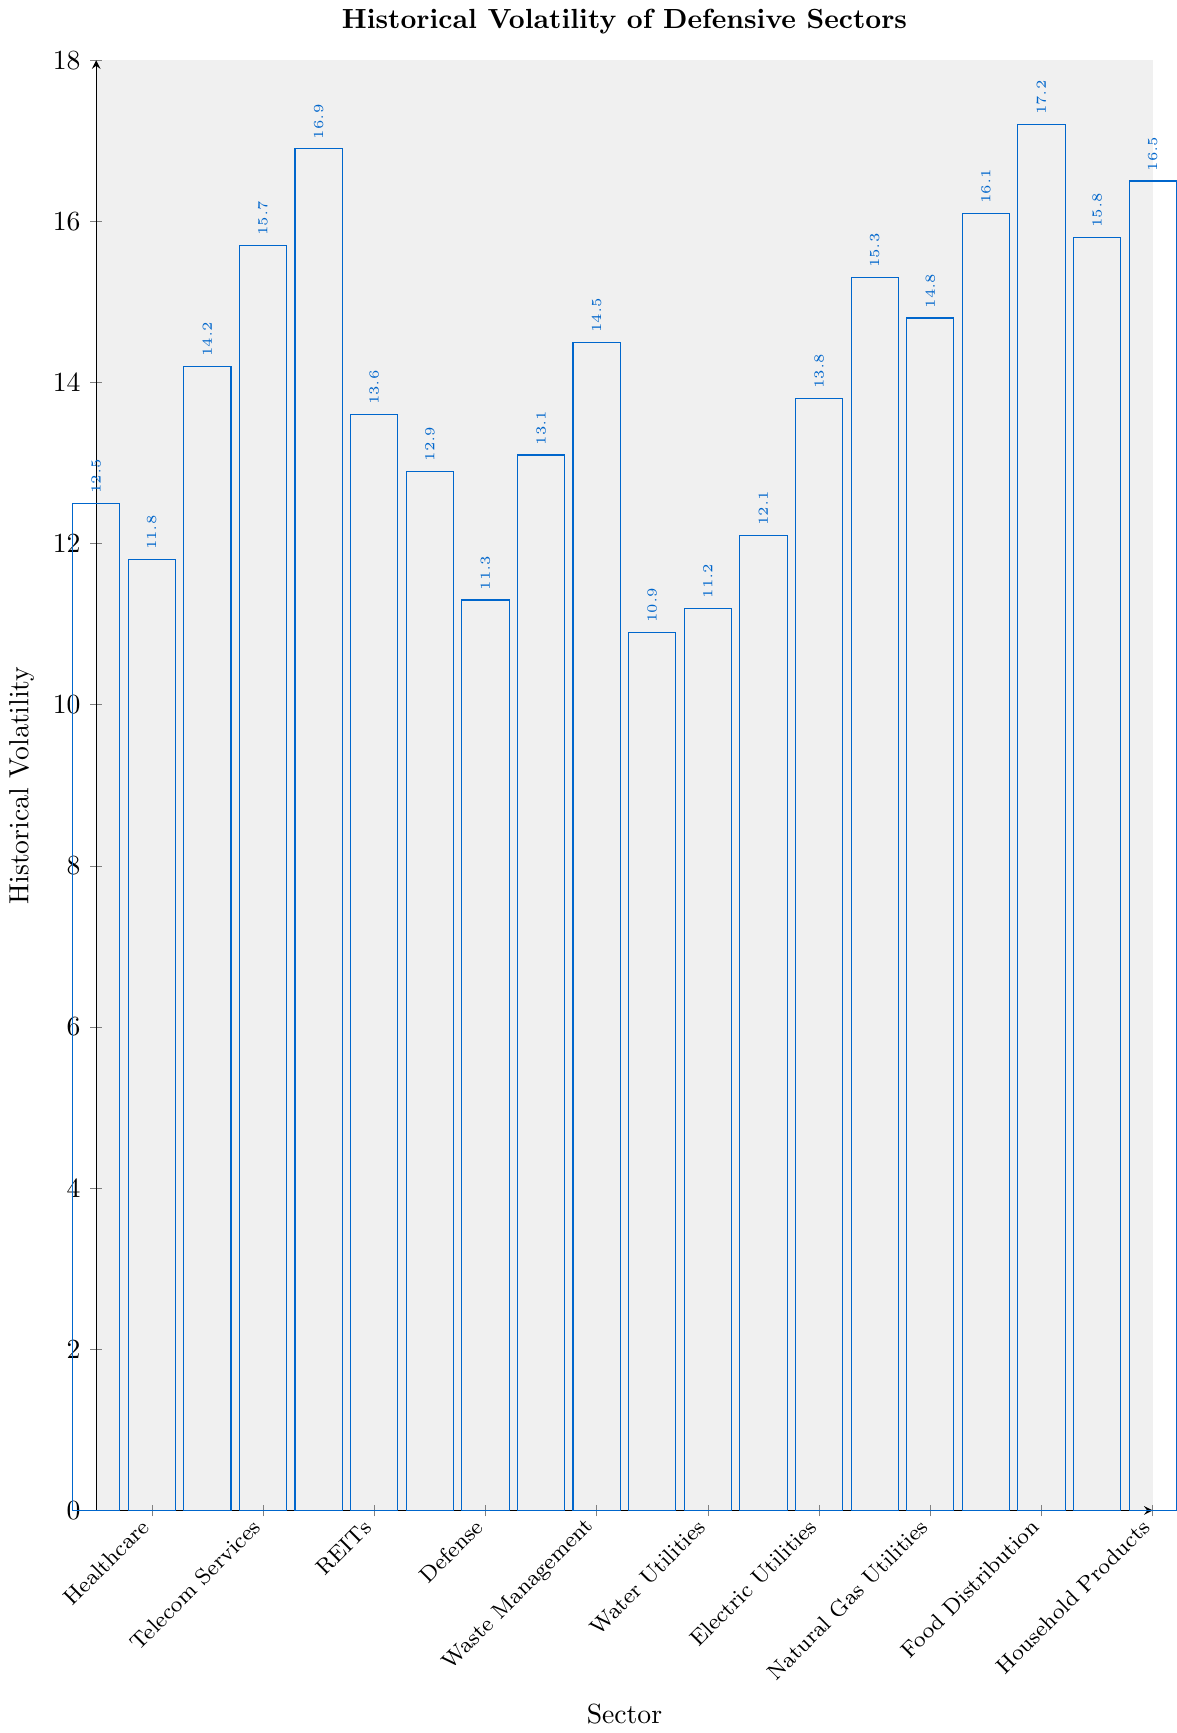Which sector has the lowest historical volatility? By visually examining the figure, observe which bar is the shortest. The shortest bar corresponds to the Food Distribution sector.
Answer: Food Distribution Which sector has the highest historical volatility? By visually examining the figure, observe which bar is the tallest. The tallest bar corresponds to the Wireless Telecommunication Services sector.
Answer: Wireless Telecommunication Services Among the Utilities sectors (Utilities, Water Utilities, Electric Utilities, and Natural Gas Utilities), which has the highest historical volatility? Identify the bars for the Utilities sectors by their position on the x-axis. Compare their heights and note that Natural Gas Utilities has the tallest bar among these.
Answer: Natural Gas Utilities What's the difference in historical volatility between the Healthcare and Managed Healthcare sectors? Locate the bars corresponding to Healthcare and Managed Healthcare. Healthcare's historical volatility is 14.2, while Managed Healthcare's is 14.8. The difference is 14.8 - 14.2.
Answer: 0.6 What is the average historical volatility of the Consumer Staples, Healthcare, and Defense sectors? Sum the historical volatilities of Consumer Staples (11.8), Healthcare (14.2), and Defense (13.6), then divide by the number of sectors: (11.8 + 14.2 + 13.6) / 3.
Answer: 13.2 What is the average historical volatility of all sectors shown in the figure? Sum up all the historical volatility values and divide by the number of sectors: (12.5 + 11.8 + 14.2 + 15.7 + 16.9 + 13.6 + 12.9 + 11.3 + 13.1 + 14.5 + 10.9 + 11.2 + 12.1 + 13.8 + 15.3 + 14.8 + 16.1 + 17.2 + 15.8 + 16.5) / 20.
Answer: 14.05 Which sector has slightly higher historical volatility: Beverages or Household Products? Compare the heights of the bars for Beverages and Household Products. Beverages has a historical volatility of 12.1, whereas Household Products has 11.2.
Answer: Beverages Among the sectors with historical volatility above 16, which has the lowest value? Identify sectors with historical volatility above 16: Wireless Telecommunication Services (17.2), Residential REITs (15.8), Industrial REITs (16.5), and Medical Devices (16.1). Medical Devices has the lowest among these.
Answer: Medical Devices Which sector has a historical volatility closest to 15? Visually inspect the bars and their label values to find the sector with volatility closest to 15. Pharmaceuticals (15.3), Managed Healthcare (14.8), and Residential REITs (15.8) closely match. Among these, Pharmaceuticals closest to 15.
Answer: Pharmaceuticals 